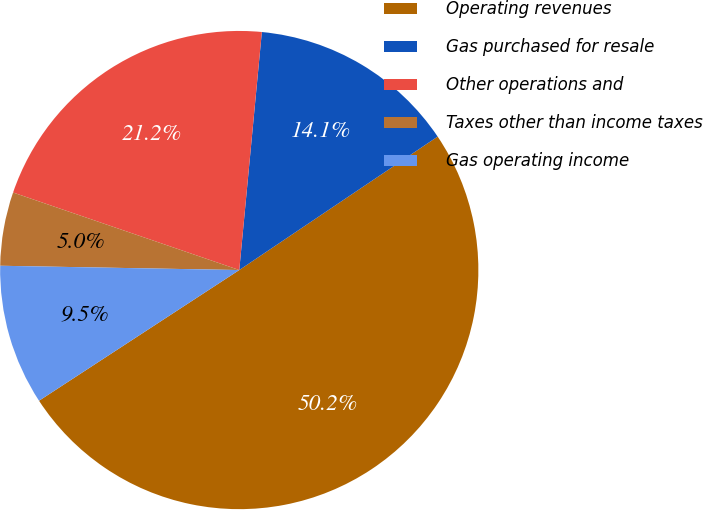Convert chart to OTSL. <chart><loc_0><loc_0><loc_500><loc_500><pie_chart><fcel>Operating revenues<fcel>Gas purchased for resale<fcel>Other operations and<fcel>Taxes other than income taxes<fcel>Gas operating income<nl><fcel>50.22%<fcel>14.07%<fcel>21.25%<fcel>4.97%<fcel>9.49%<nl></chart> 